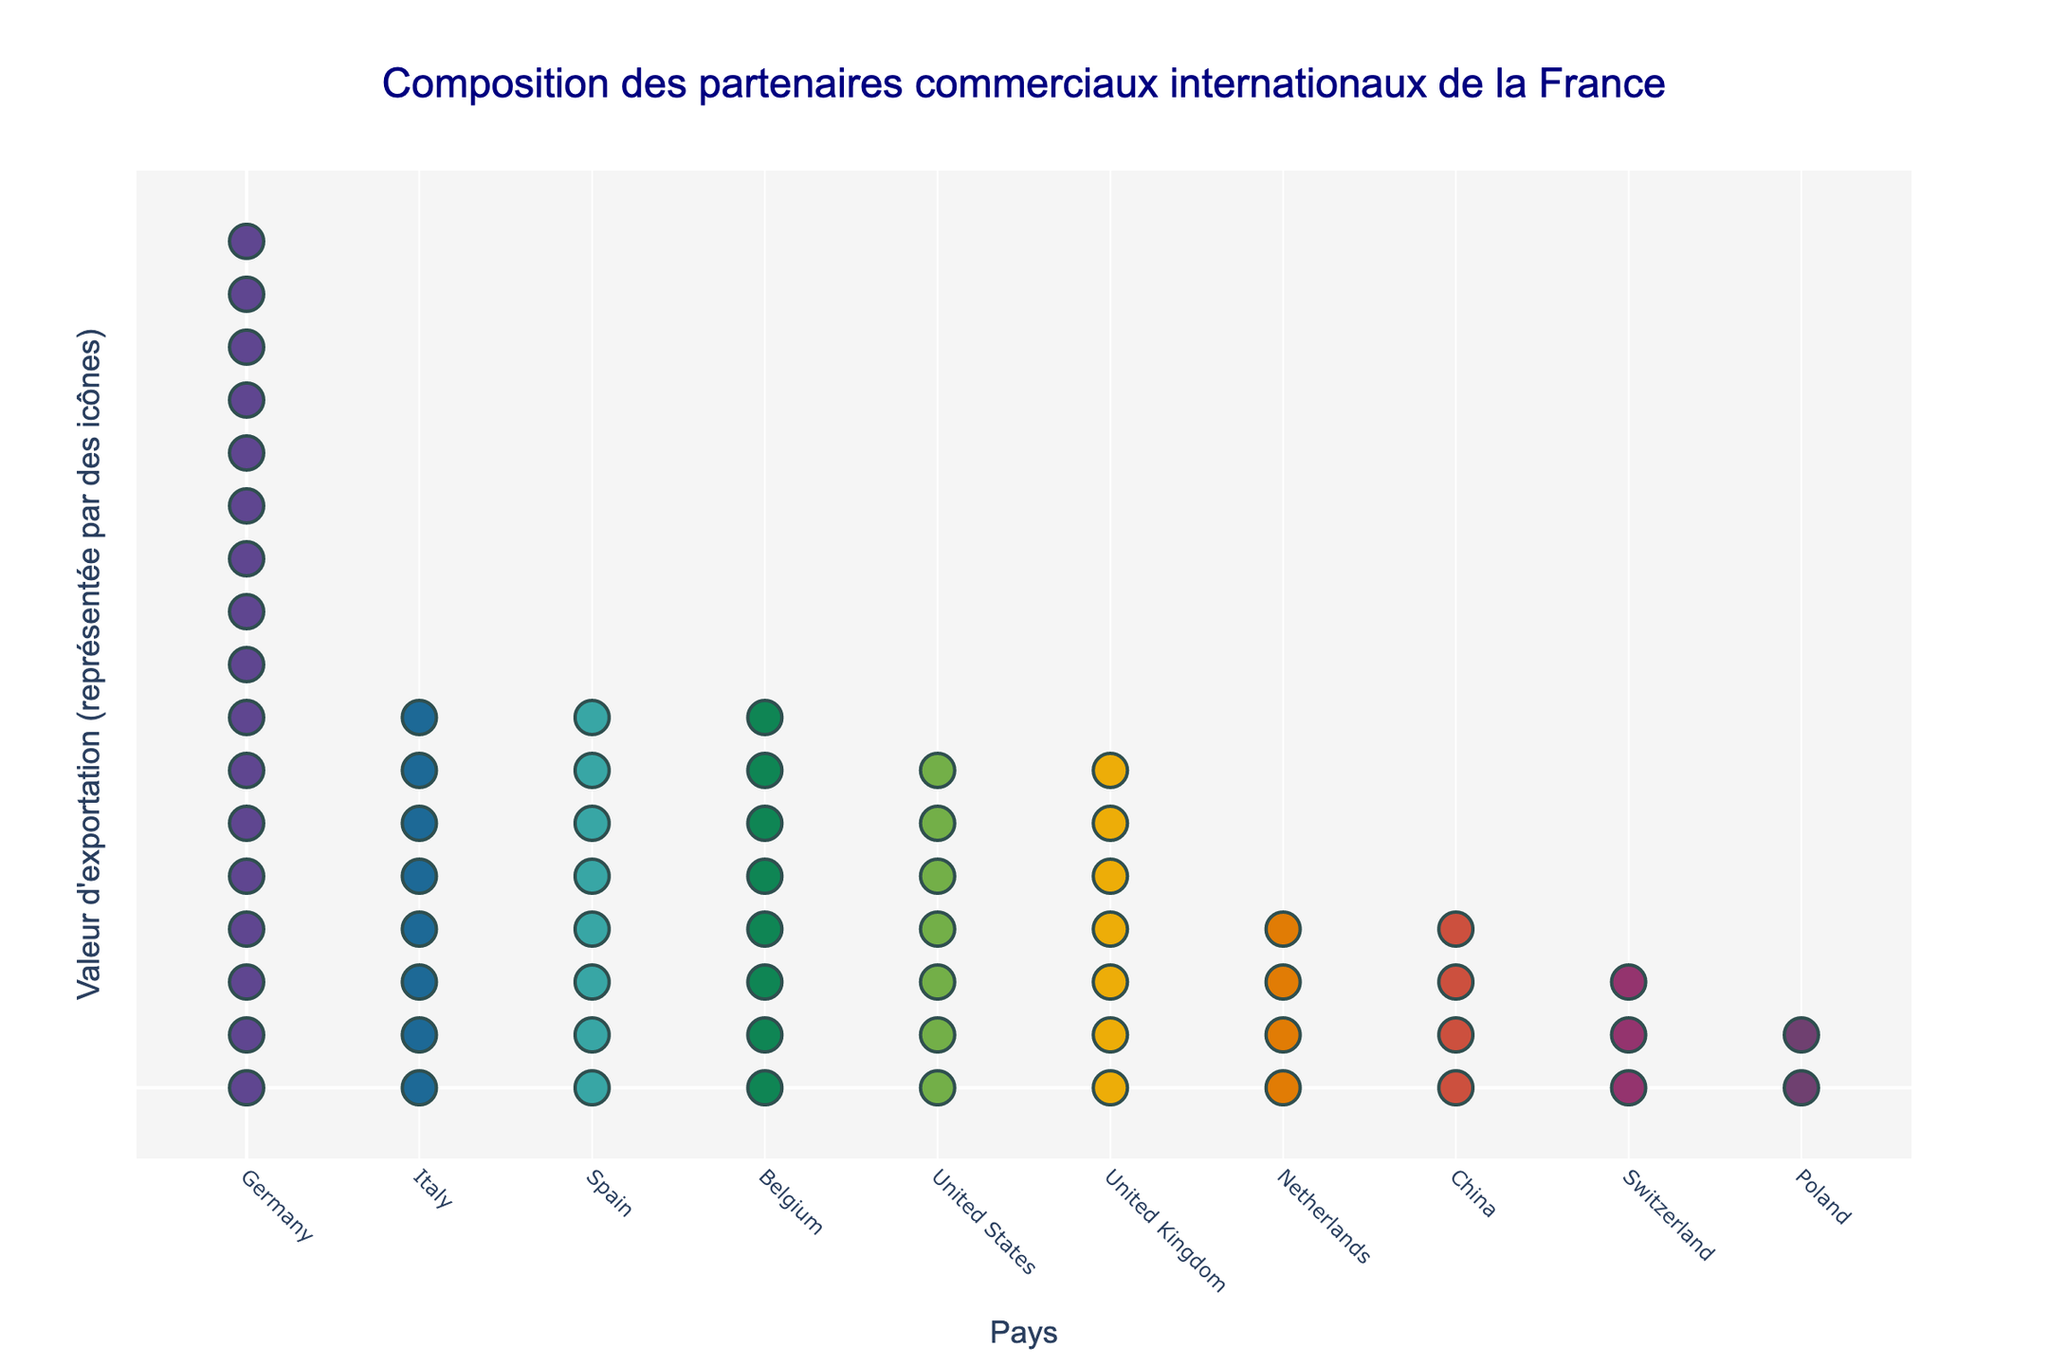What is the title of this plot? The title is located at the top of the figure and it reads: "Composition des partenaires commerciaux internationaux de la France".
Answer: Composition des partenaires commerciaux internationaux de la France Which country has the highest export value represented in the figure? By observing the number of icons, Germany has the highest export value with 17 icons.
Answer: Germany How many countries have an export value represented by exactly 8 icons? There are three countries with exactly 8 icons: Italy, Spain, and Belgium.
Answer: 3 Which country has the lowest export value represented in the figure and how many icons represent it? The country with the lowest export value is Poland, represented by 2 icons.
Answer: Poland, 2 What are the total export values (in billions of EUR) of the countries with 4 icons each? The countries with 4 icons each are the Netherlands and China. Their export values are 20 billion EUR and 18 billion EUR respectively. So the total export value is 20 + 18 = 38 billion EUR.
Answer: 38 billion EUR Compare the export values between Germany and the United States. How many more billions of EUR does Germany export than the United States? Germany has 17 icons (representing 86 billion EUR) while the United States has 7 icons (35 billion EUR). The difference is 86 - 35 = 51 billion EUR.
Answer: 51 billion EUR What is the average export value (in billions of EUR) of the United Kingdom and Switzerland? The UK and Switzerland have export values of 33 billion EUR and 17 billion EUR respectively. The average export value is (33 + 17) / 2 = 25 billion EUR.
Answer: 25 billion EUR How many total icons are used to represent all the countries in the plot? Summing up the number of icons for each country (17 + 8 + 8 + 8 + 7 + 7 + 4 + 4 + 3 + 2) gives a total of 68 icons.
Answer: 68 Which countries have more icons than the United Kingdom? Germany has 17 icons and Italy, Spain, and Belgium each have 8 icons, which are all more than the UK's 7 icons.
Answer: Germany, Italy, Spain, Belgium Compare the export values of Italy and Belgium. Is there a significant difference? Both Italy and Belgium have 8 icons representing their export values, which are very close. Italy has 42 billion EUR and Belgium has 38 billion EUR. The difference is 42 - 38 = 4 billion EUR, which is relatively small.
Answer: No significant difference 